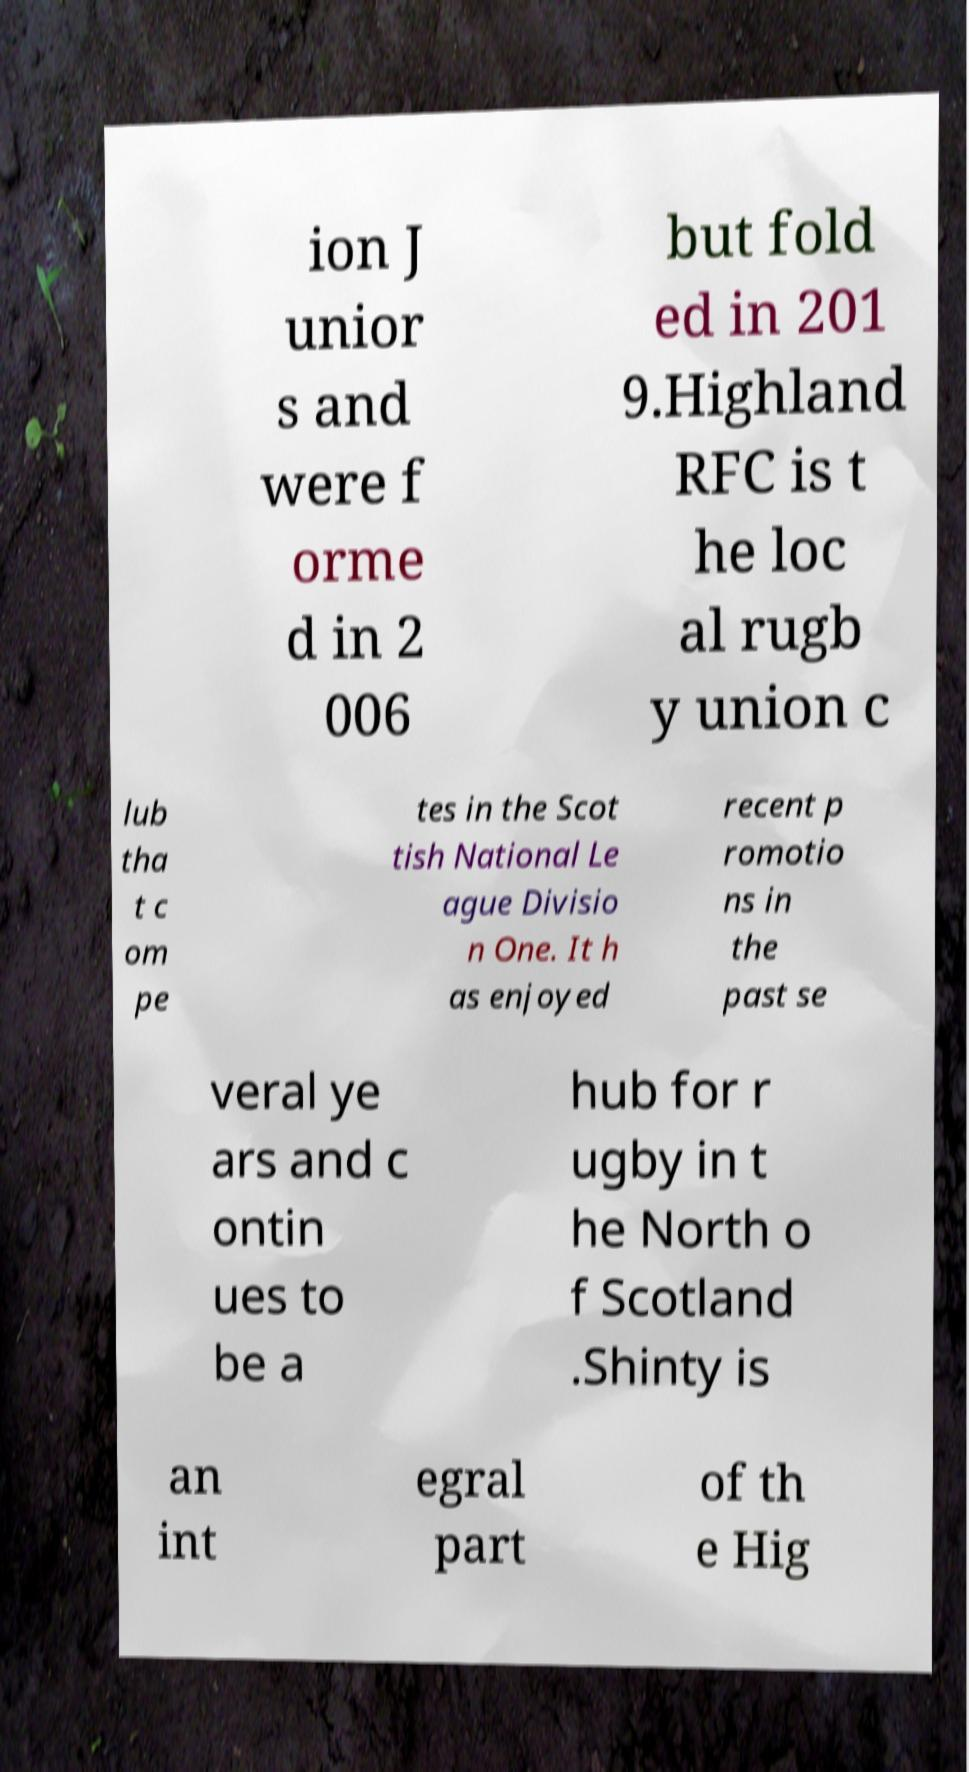Can you accurately transcribe the text from the provided image for me? ion J unior s and were f orme d in 2 006 but fold ed in 201 9.Highland RFC is t he loc al rugb y union c lub tha t c om pe tes in the Scot tish National Le ague Divisio n One. It h as enjoyed recent p romotio ns in the past se veral ye ars and c ontin ues to be a hub for r ugby in t he North o f Scotland .Shinty is an int egral part of th e Hig 